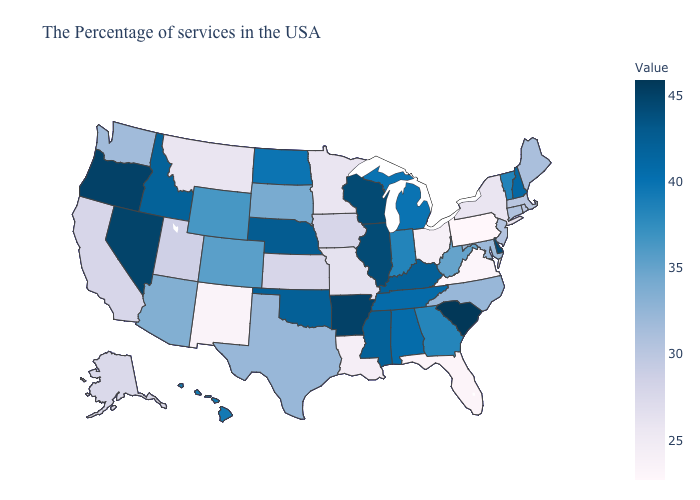Does North Dakota have a higher value than Kentucky?
Give a very brief answer. No. Does the map have missing data?
Quick response, please. No. Among the states that border Alabama , which have the highest value?
Short answer required. Mississippi. Does Louisiana have the highest value in the USA?
Write a very short answer. No. Among the states that border Vermont , does New Hampshire have the lowest value?
Keep it brief. No. 